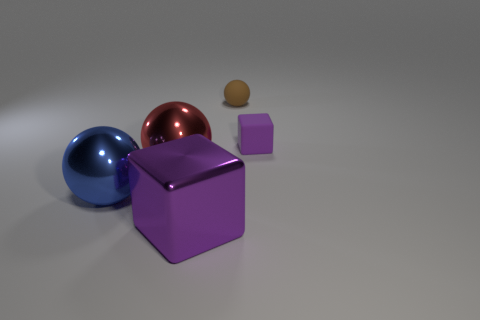Subtract all small balls. How many balls are left? 2 Subtract all cubes. How many objects are left? 3 Add 1 red metallic spheres. How many objects exist? 6 Subtract 3 spheres. How many spheres are left? 0 Subtract all red spheres. How many spheres are left? 2 Add 4 purple matte blocks. How many purple matte blocks exist? 5 Subtract 0 cyan spheres. How many objects are left? 5 Subtract all blue cubes. Subtract all gray cylinders. How many cubes are left? 2 Subtract all gray cylinders. How many blue cubes are left? 0 Subtract all metallic objects. Subtract all matte blocks. How many objects are left? 1 